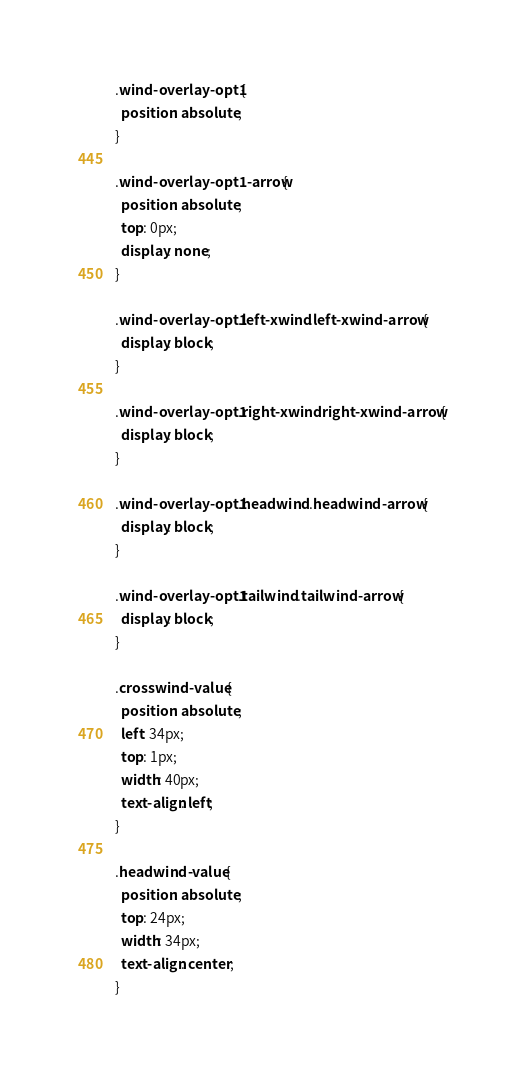Convert code to text. <code><loc_0><loc_0><loc_500><loc_500><_CSS_>.wind-overlay-opt1 {
  position: absolute;
}

.wind-overlay-opt1-arrow {
  position: absolute;
  top: 0px;
  display: none;
}

.wind-overlay-opt1.left-xwind .left-xwind-arrow {
  display: block;
}

.wind-overlay-opt1.right-xwind .right-xwind-arrow {
  display: block;
}

.wind-overlay-opt1.headwind .headwind-arrow {
  display: block;
}

.wind-overlay-opt1.tailwind .tailwind-arrow {
  display: block;
}

.crosswind-value {
  position: absolute;
  left: 34px;
  top: 1px;
  width: 40px;
  text-align: left;
}

.headwind-value {
  position: absolute;
  top: 24px;
  width: 34px;
  text-align: center;
}</code> 